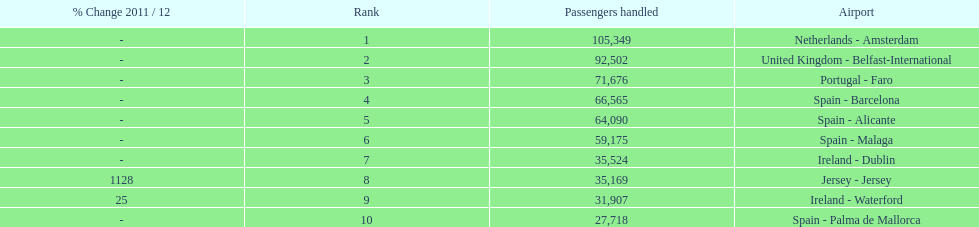How many airports are listed? 10. 